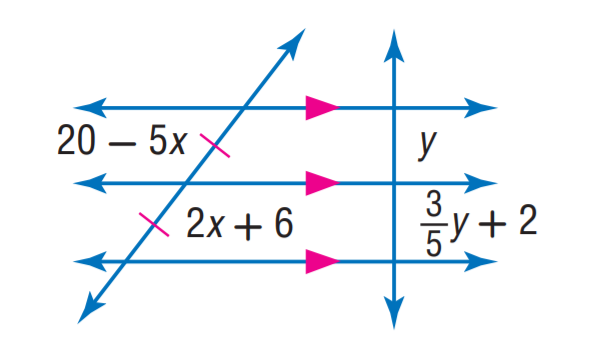Question: Find y.
Choices:
A. 2
B. 3
C. 4
D. 5
Answer with the letter. Answer: D Question: Find x.
Choices:
A. 2
B. 3
C. 4
D. 5
Answer with the letter. Answer: A 